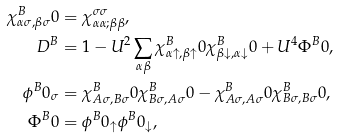Convert formula to latex. <formula><loc_0><loc_0><loc_500><loc_500>\chi _ { \alpha \sigma , \beta \sigma } ^ { B } 0 & = \chi _ { \alpha \alpha ; \beta \beta } ^ { \sigma \sigma } , \\ D ^ { B } & = 1 - U ^ { 2 } \sum _ { \alpha \beta } \chi _ { \alpha \uparrow , \beta \uparrow } ^ { B } 0 \chi _ { \beta \downarrow , \alpha \downarrow } ^ { B } 0 + U ^ { 4 } \Phi ^ { B } 0 , \\ \phi ^ { B } 0 _ { \sigma } & = \chi _ { A \sigma , B \sigma } ^ { B } 0 \chi _ { B \sigma , A \sigma } ^ { B } 0 - \chi _ { A \sigma , A \sigma } ^ { B } 0 \chi _ { B \sigma , B \sigma } ^ { B } 0 , \\ \Phi ^ { B } 0 & = \phi ^ { B } 0 _ { \uparrow } \phi ^ { B } 0 _ { \downarrow } ,</formula> 